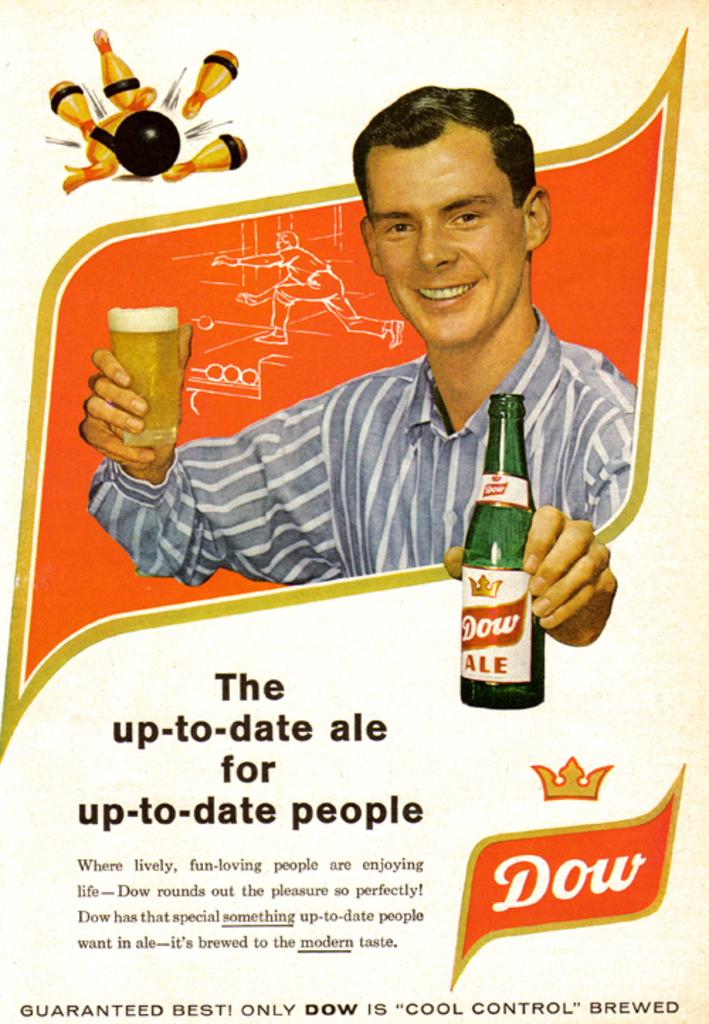<image>
Summarize the visual content of the image. An advertisement has a man and the Dow logo in the corner. 